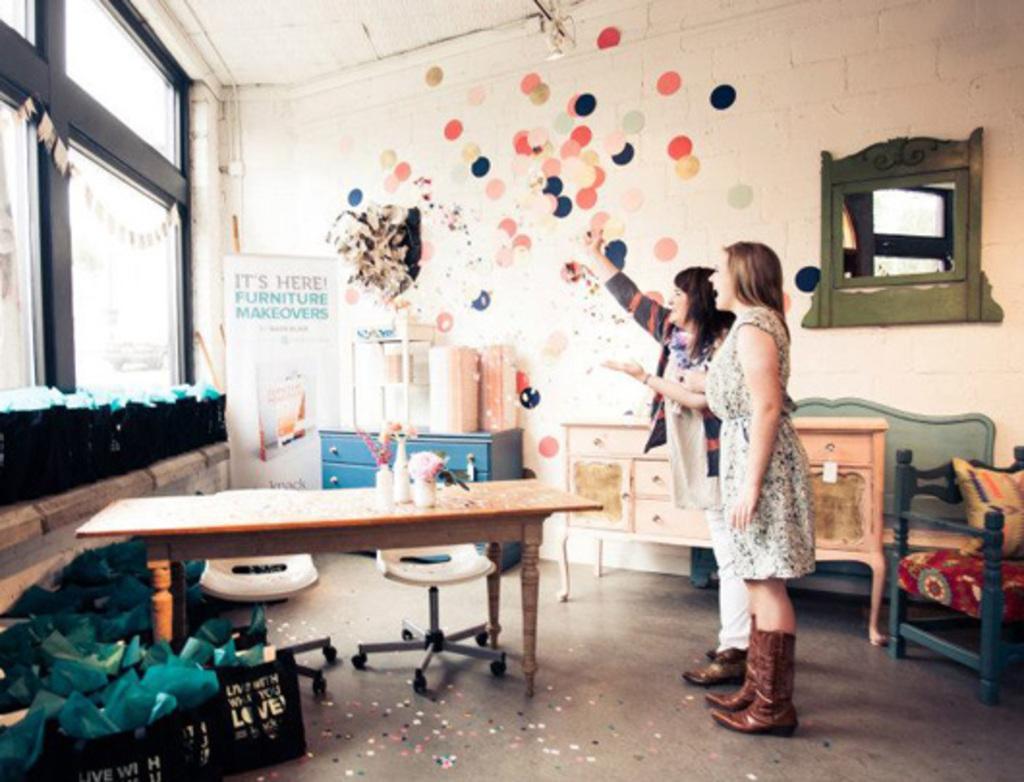How would you summarize this image in a sentence or two? In this image I can see two people are standing inside the room. There are some flower vase on the table. I can also see some colorful wall paintings,window,banner,mirror,chairs,cupboard inside the room. 